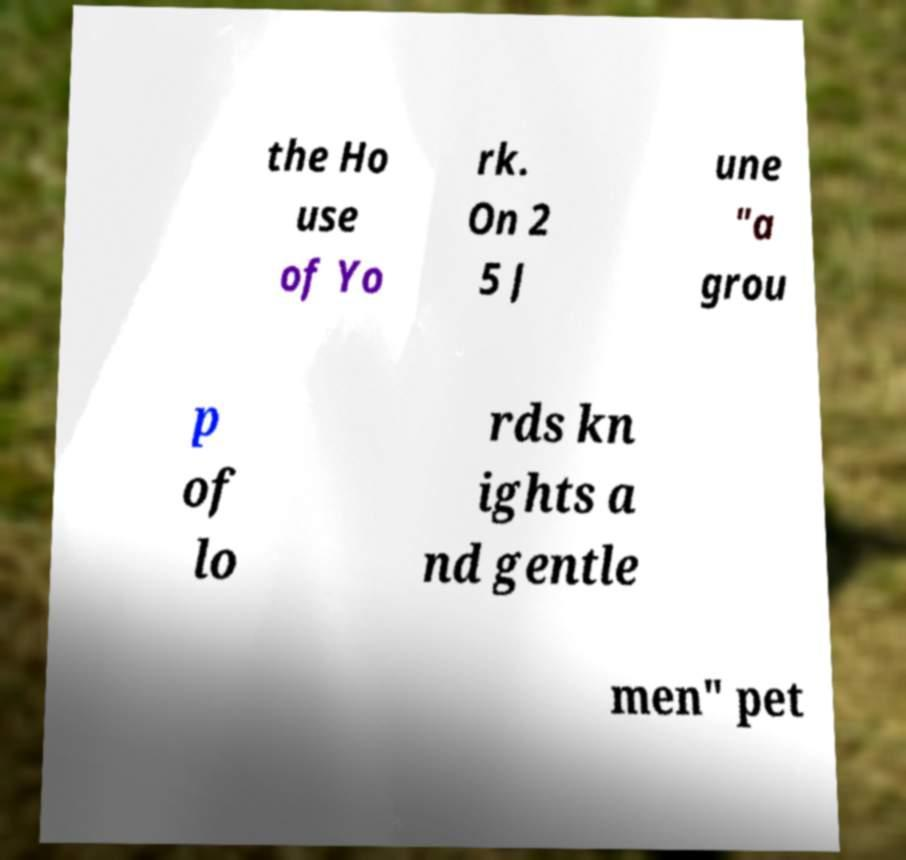Can you accurately transcribe the text from the provided image for me? the Ho use of Yo rk. On 2 5 J une "a grou p of lo rds kn ights a nd gentle men" pet 